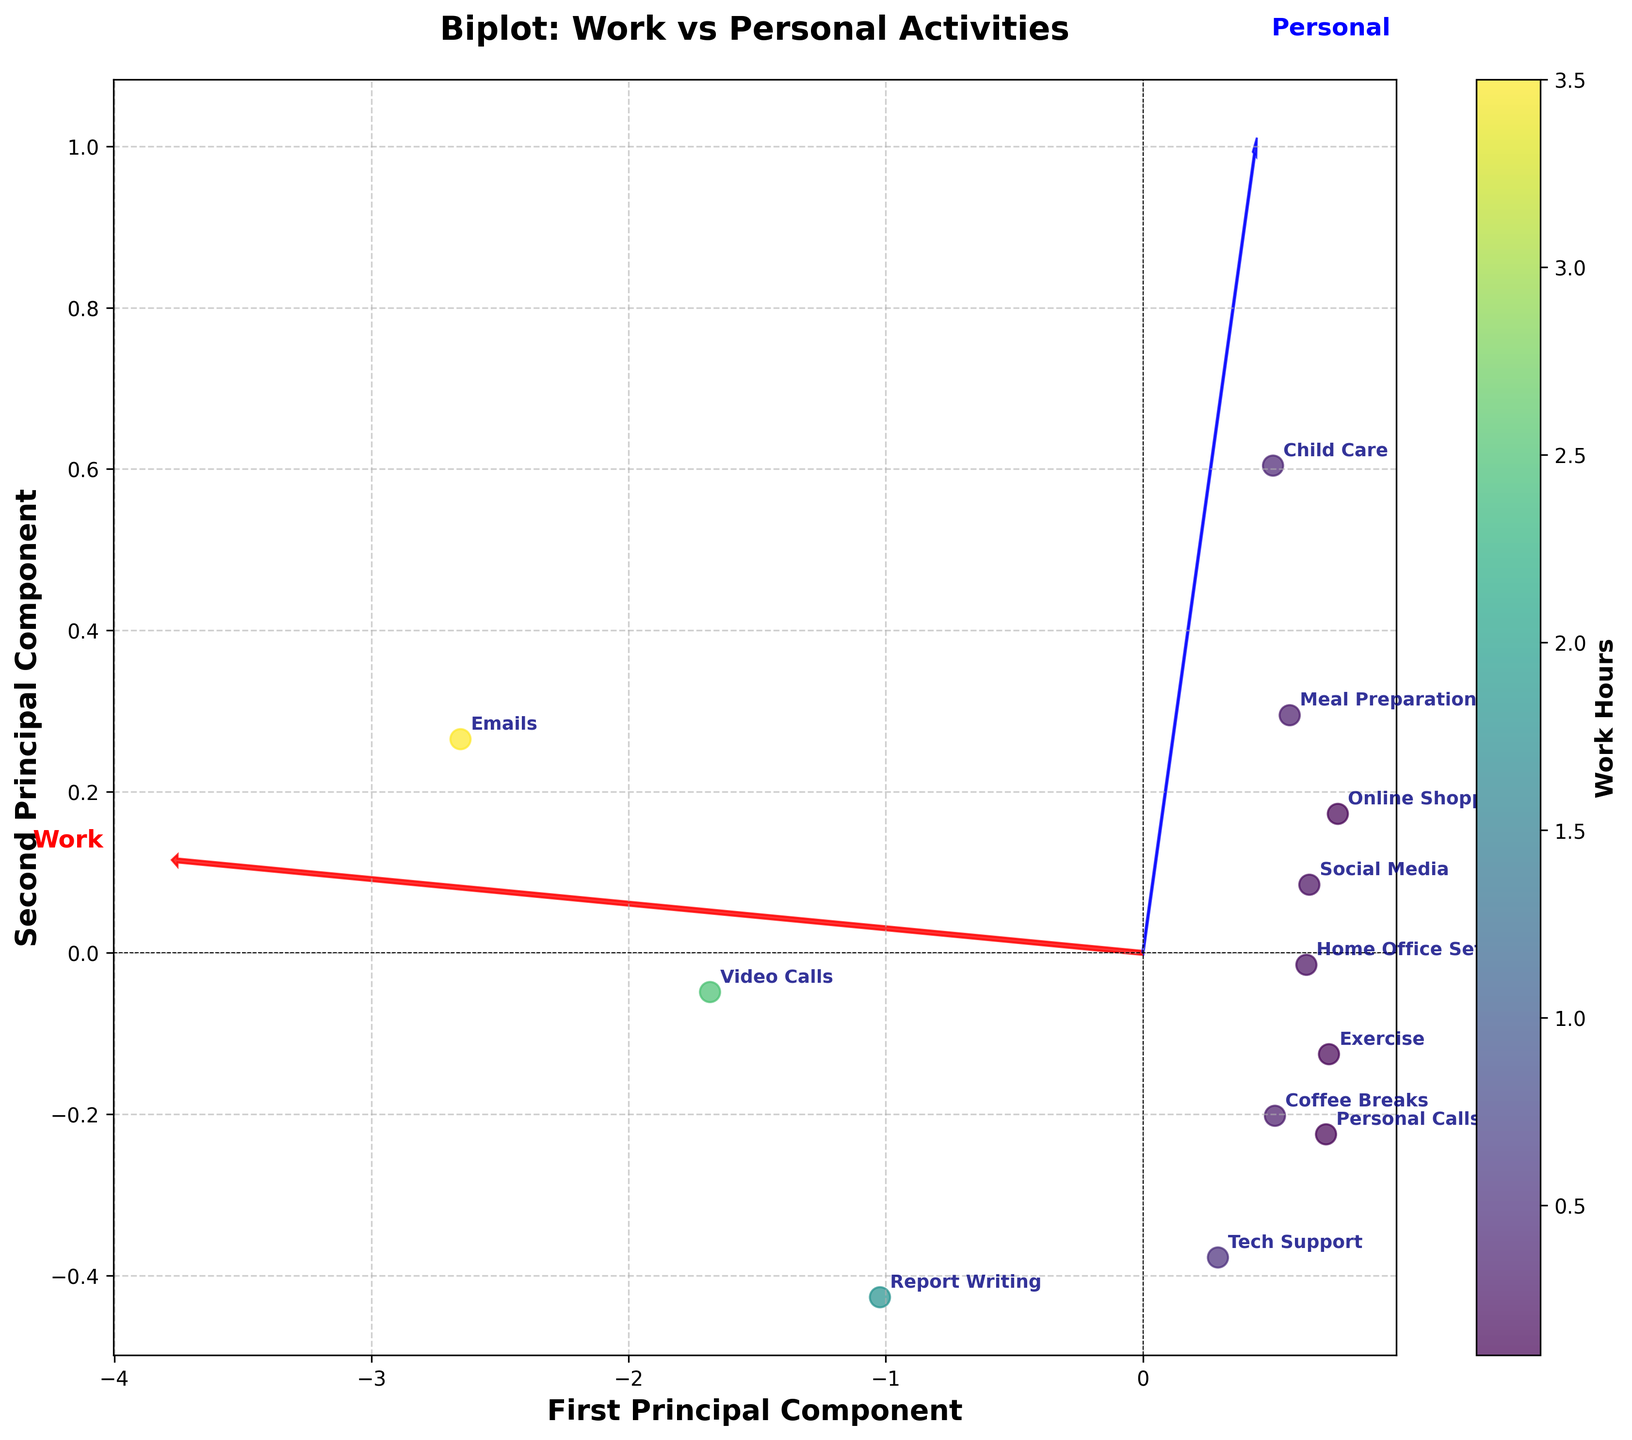What is the title of the biplot? The title of the biplot is written at the top of the figure, typically in a larger and bolder font that sums up the main theme of the visualized data.
Answer: Biplot: Work vs Personal Activities How many data points are represented in the biplot? Each task in the dataset is represented as a data point on the plot. Count the annotated labels for each task to find the total number of data points. There are 12 tasks listed, so there are 12 data points.
Answer: 12 Which activity has the highest value on the horizontal axis? To determine this, look for the data point that is furthest to the right along the first principal component (horizontal axis). Cross-reference the annotated label of that data point with the tasks.
Answer: Emails What is the range of the colorbar representing Work Hours? Observe the color gradient on the colorbar and note the minimum and maximum values indicated at either end of the colorbar.
Answer: 0 to 3.5 Which activity falls closest to the origin (0, 0) of the biplot? The origin is where both principal components intersect at the center of the plot. Find the data point that is closest to this point by checking distances of all data labels around the origin.
Answer: Home Office Setup Compare the Work Hours and Personal Hours for Video Calls. Which is higher and by how much? Find the label for Video Calls and refer to its coordinates for Work Hours and Personal Hours. Work Hours are 2.5, and Personal Hours are 0.3. Subtract the smaller value from the larger value.
Answer: Work Hours are higher by 2.2 Which activity is associated with the highest Personal Hours? Look for the data point furthest along the second principal component axis in the positive direction and cross-reference it with its label to identify the task.
Answer: Child Care Are there any activities with the same Work Hours value but different Personal Hours values? Find data points lined up vertically (same value on the horizontal axis) but exhibit a spread along the vertical axis. Compare their Personal Hours.
Answer: Yes, Coffee Breaks and Meal Preparation have the same Work Hours (0.3) but different Personal Hours Which feature vector (Work or Personal) is more influential in the first principal component? Examine the arrows representing the feature vectors. The length of the arrow in the direction of the first principal component indicates its influence. Compare the relative lengths.
Answer: Work What is the relationship between exercise and online shopping based on their positions on the biplot? Look at the positions of Exercise and Online Shopping on the plot. They are close in terms of both principal components, indicating they have similar patterns in terms of Work and Personal Hours.
Answer: Similar pattern 